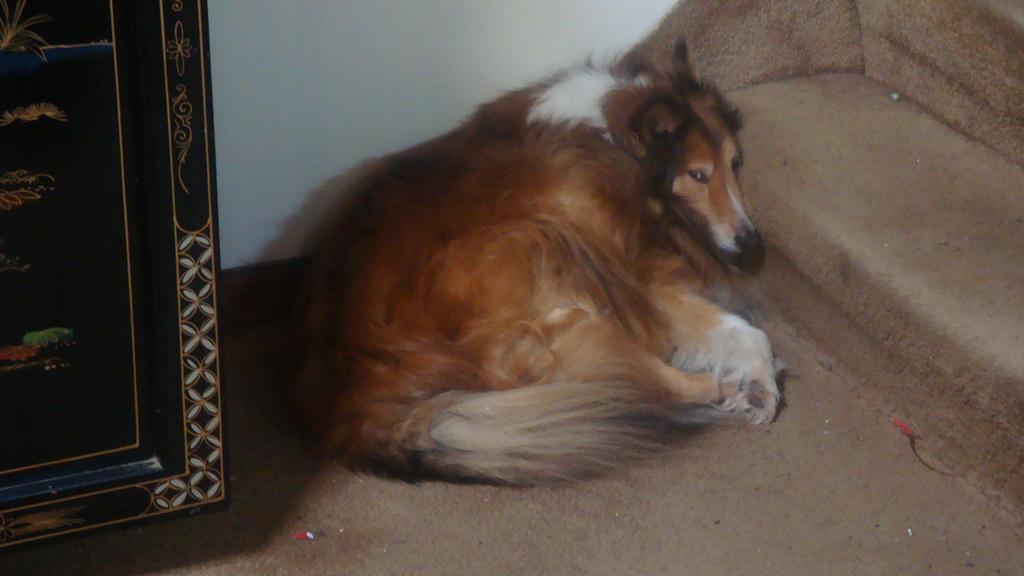Describe this image in one or two sentences. This is the dog sitting on the floor. This looks like a wooden object. I think these are the stairs. 